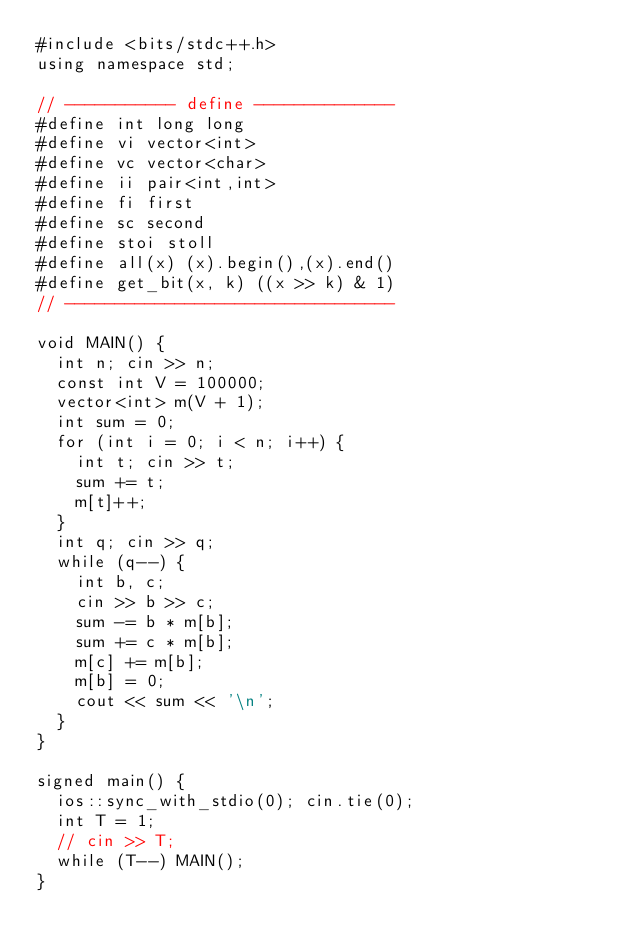Convert code to text. <code><loc_0><loc_0><loc_500><loc_500><_C++_>#include <bits/stdc++.h>
using namespace std;

// ----------- define --------------
#define int long long
#define vi vector<int>
#define vc vector<char>
#define ii pair<int,int>
#define fi first
#define sc second
#define stoi stoll
#define all(x) (x).begin(),(x).end()
#define get_bit(x, k) ((x >> k) & 1)
// ---------------------------------

void MAIN() {
  int n; cin >> n;
  const int V = 100000;
  vector<int> m(V + 1);
  int sum = 0;
  for (int i = 0; i < n; i++) {
    int t; cin >> t;
    sum += t;
    m[t]++;
  }
  int q; cin >> q;
  while (q--) {
    int b, c;
    cin >> b >> c;
    sum -= b * m[b];
    sum += c * m[b];
    m[c] += m[b];
    m[b] = 0;
    cout << sum << '\n';
  }
}

signed main() {
  ios::sync_with_stdio(0); cin.tie(0);
  int T = 1;
  // cin >> T;
  while (T--) MAIN();
}
</code> 